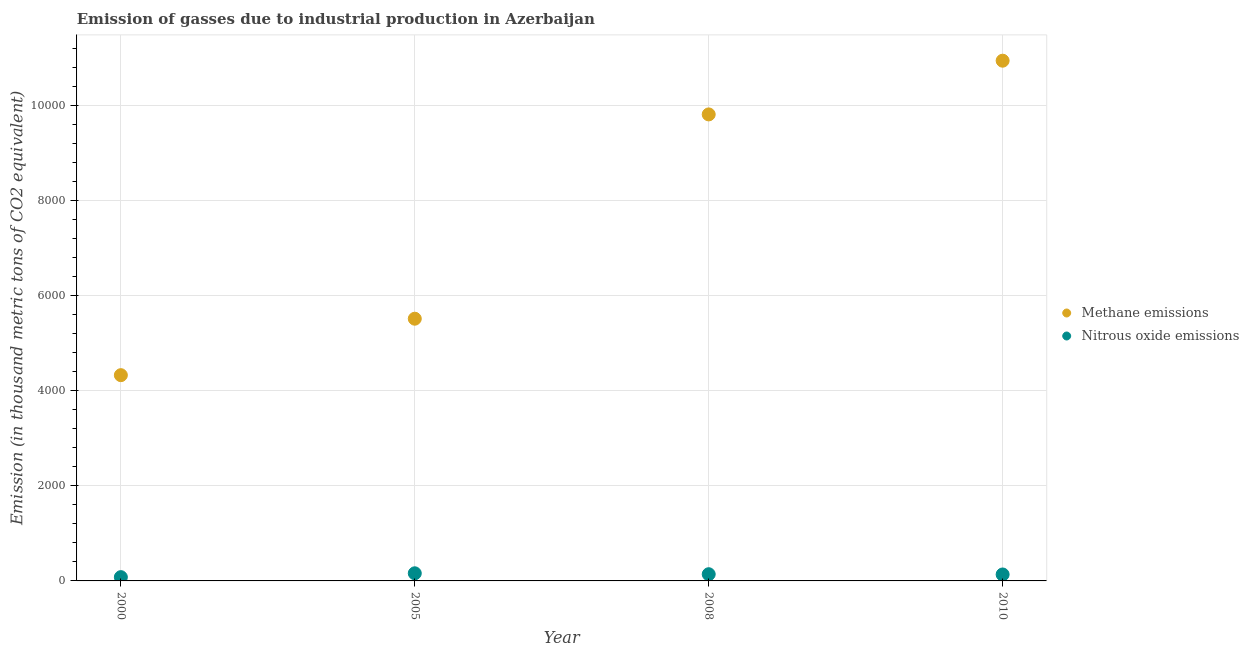How many different coloured dotlines are there?
Give a very brief answer. 2. Is the number of dotlines equal to the number of legend labels?
Make the answer very short. Yes. What is the amount of methane emissions in 2008?
Your answer should be very brief. 9812.4. Across all years, what is the maximum amount of nitrous oxide emissions?
Give a very brief answer. 160.4. Across all years, what is the minimum amount of methane emissions?
Keep it short and to the point. 4327.8. In which year was the amount of nitrous oxide emissions minimum?
Ensure brevity in your answer.  2000. What is the total amount of methane emissions in the graph?
Make the answer very short. 3.06e+04. What is the difference between the amount of methane emissions in 2005 and that in 2008?
Offer a very short reply. -4297.2. What is the difference between the amount of methane emissions in 2000 and the amount of nitrous oxide emissions in 2008?
Keep it short and to the point. 4186.8. What is the average amount of nitrous oxide emissions per year?
Offer a terse response. 129.15. In the year 2005, what is the difference between the amount of methane emissions and amount of nitrous oxide emissions?
Offer a very short reply. 5354.8. In how many years, is the amount of nitrous oxide emissions greater than 8800 thousand metric tons?
Ensure brevity in your answer.  0. What is the ratio of the amount of nitrous oxide emissions in 2005 to that in 2008?
Your answer should be compact. 1.14. Is the difference between the amount of methane emissions in 2005 and 2008 greater than the difference between the amount of nitrous oxide emissions in 2005 and 2008?
Keep it short and to the point. No. What is the difference between the highest and the second highest amount of nitrous oxide emissions?
Offer a very short reply. 19.4. What is the difference between the highest and the lowest amount of nitrous oxide emissions?
Make the answer very short. 80.9. Is the amount of nitrous oxide emissions strictly less than the amount of methane emissions over the years?
Keep it short and to the point. Yes. How many years are there in the graph?
Give a very brief answer. 4. What is the difference between two consecutive major ticks on the Y-axis?
Your answer should be compact. 2000. Are the values on the major ticks of Y-axis written in scientific E-notation?
Offer a terse response. No. Does the graph contain any zero values?
Ensure brevity in your answer.  No. Does the graph contain grids?
Provide a short and direct response. Yes. What is the title of the graph?
Your answer should be compact. Emission of gasses due to industrial production in Azerbaijan. Does "IMF nonconcessional" appear as one of the legend labels in the graph?
Offer a very short reply. No. What is the label or title of the X-axis?
Give a very brief answer. Year. What is the label or title of the Y-axis?
Your response must be concise. Emission (in thousand metric tons of CO2 equivalent). What is the Emission (in thousand metric tons of CO2 equivalent) in Methane emissions in 2000?
Your answer should be very brief. 4327.8. What is the Emission (in thousand metric tons of CO2 equivalent) in Nitrous oxide emissions in 2000?
Ensure brevity in your answer.  79.5. What is the Emission (in thousand metric tons of CO2 equivalent) in Methane emissions in 2005?
Provide a short and direct response. 5515.2. What is the Emission (in thousand metric tons of CO2 equivalent) in Nitrous oxide emissions in 2005?
Your answer should be very brief. 160.4. What is the Emission (in thousand metric tons of CO2 equivalent) in Methane emissions in 2008?
Make the answer very short. 9812.4. What is the Emission (in thousand metric tons of CO2 equivalent) of Nitrous oxide emissions in 2008?
Keep it short and to the point. 141. What is the Emission (in thousand metric tons of CO2 equivalent) in Methane emissions in 2010?
Your response must be concise. 1.09e+04. What is the Emission (in thousand metric tons of CO2 equivalent) in Nitrous oxide emissions in 2010?
Provide a short and direct response. 135.7. Across all years, what is the maximum Emission (in thousand metric tons of CO2 equivalent) in Methane emissions?
Provide a succinct answer. 1.09e+04. Across all years, what is the maximum Emission (in thousand metric tons of CO2 equivalent) of Nitrous oxide emissions?
Make the answer very short. 160.4. Across all years, what is the minimum Emission (in thousand metric tons of CO2 equivalent) in Methane emissions?
Your answer should be very brief. 4327.8. Across all years, what is the minimum Emission (in thousand metric tons of CO2 equivalent) in Nitrous oxide emissions?
Your answer should be compact. 79.5. What is the total Emission (in thousand metric tons of CO2 equivalent) of Methane emissions in the graph?
Provide a short and direct response. 3.06e+04. What is the total Emission (in thousand metric tons of CO2 equivalent) of Nitrous oxide emissions in the graph?
Your answer should be compact. 516.6. What is the difference between the Emission (in thousand metric tons of CO2 equivalent) of Methane emissions in 2000 and that in 2005?
Your answer should be very brief. -1187.4. What is the difference between the Emission (in thousand metric tons of CO2 equivalent) in Nitrous oxide emissions in 2000 and that in 2005?
Give a very brief answer. -80.9. What is the difference between the Emission (in thousand metric tons of CO2 equivalent) in Methane emissions in 2000 and that in 2008?
Offer a terse response. -5484.6. What is the difference between the Emission (in thousand metric tons of CO2 equivalent) of Nitrous oxide emissions in 2000 and that in 2008?
Your answer should be compact. -61.5. What is the difference between the Emission (in thousand metric tons of CO2 equivalent) of Methane emissions in 2000 and that in 2010?
Make the answer very short. -6614.3. What is the difference between the Emission (in thousand metric tons of CO2 equivalent) in Nitrous oxide emissions in 2000 and that in 2010?
Your response must be concise. -56.2. What is the difference between the Emission (in thousand metric tons of CO2 equivalent) of Methane emissions in 2005 and that in 2008?
Ensure brevity in your answer.  -4297.2. What is the difference between the Emission (in thousand metric tons of CO2 equivalent) in Nitrous oxide emissions in 2005 and that in 2008?
Offer a terse response. 19.4. What is the difference between the Emission (in thousand metric tons of CO2 equivalent) of Methane emissions in 2005 and that in 2010?
Keep it short and to the point. -5426.9. What is the difference between the Emission (in thousand metric tons of CO2 equivalent) in Nitrous oxide emissions in 2005 and that in 2010?
Offer a very short reply. 24.7. What is the difference between the Emission (in thousand metric tons of CO2 equivalent) of Methane emissions in 2008 and that in 2010?
Provide a succinct answer. -1129.7. What is the difference between the Emission (in thousand metric tons of CO2 equivalent) of Methane emissions in 2000 and the Emission (in thousand metric tons of CO2 equivalent) of Nitrous oxide emissions in 2005?
Offer a very short reply. 4167.4. What is the difference between the Emission (in thousand metric tons of CO2 equivalent) in Methane emissions in 2000 and the Emission (in thousand metric tons of CO2 equivalent) in Nitrous oxide emissions in 2008?
Your answer should be very brief. 4186.8. What is the difference between the Emission (in thousand metric tons of CO2 equivalent) of Methane emissions in 2000 and the Emission (in thousand metric tons of CO2 equivalent) of Nitrous oxide emissions in 2010?
Your response must be concise. 4192.1. What is the difference between the Emission (in thousand metric tons of CO2 equivalent) in Methane emissions in 2005 and the Emission (in thousand metric tons of CO2 equivalent) in Nitrous oxide emissions in 2008?
Your answer should be very brief. 5374.2. What is the difference between the Emission (in thousand metric tons of CO2 equivalent) in Methane emissions in 2005 and the Emission (in thousand metric tons of CO2 equivalent) in Nitrous oxide emissions in 2010?
Your answer should be compact. 5379.5. What is the difference between the Emission (in thousand metric tons of CO2 equivalent) of Methane emissions in 2008 and the Emission (in thousand metric tons of CO2 equivalent) of Nitrous oxide emissions in 2010?
Your response must be concise. 9676.7. What is the average Emission (in thousand metric tons of CO2 equivalent) in Methane emissions per year?
Ensure brevity in your answer.  7649.38. What is the average Emission (in thousand metric tons of CO2 equivalent) of Nitrous oxide emissions per year?
Your answer should be compact. 129.15. In the year 2000, what is the difference between the Emission (in thousand metric tons of CO2 equivalent) in Methane emissions and Emission (in thousand metric tons of CO2 equivalent) in Nitrous oxide emissions?
Give a very brief answer. 4248.3. In the year 2005, what is the difference between the Emission (in thousand metric tons of CO2 equivalent) of Methane emissions and Emission (in thousand metric tons of CO2 equivalent) of Nitrous oxide emissions?
Provide a succinct answer. 5354.8. In the year 2008, what is the difference between the Emission (in thousand metric tons of CO2 equivalent) in Methane emissions and Emission (in thousand metric tons of CO2 equivalent) in Nitrous oxide emissions?
Your response must be concise. 9671.4. In the year 2010, what is the difference between the Emission (in thousand metric tons of CO2 equivalent) of Methane emissions and Emission (in thousand metric tons of CO2 equivalent) of Nitrous oxide emissions?
Your answer should be very brief. 1.08e+04. What is the ratio of the Emission (in thousand metric tons of CO2 equivalent) of Methane emissions in 2000 to that in 2005?
Offer a terse response. 0.78. What is the ratio of the Emission (in thousand metric tons of CO2 equivalent) of Nitrous oxide emissions in 2000 to that in 2005?
Offer a very short reply. 0.5. What is the ratio of the Emission (in thousand metric tons of CO2 equivalent) in Methane emissions in 2000 to that in 2008?
Your answer should be very brief. 0.44. What is the ratio of the Emission (in thousand metric tons of CO2 equivalent) in Nitrous oxide emissions in 2000 to that in 2008?
Offer a terse response. 0.56. What is the ratio of the Emission (in thousand metric tons of CO2 equivalent) in Methane emissions in 2000 to that in 2010?
Ensure brevity in your answer.  0.4. What is the ratio of the Emission (in thousand metric tons of CO2 equivalent) in Nitrous oxide emissions in 2000 to that in 2010?
Ensure brevity in your answer.  0.59. What is the ratio of the Emission (in thousand metric tons of CO2 equivalent) of Methane emissions in 2005 to that in 2008?
Provide a succinct answer. 0.56. What is the ratio of the Emission (in thousand metric tons of CO2 equivalent) of Nitrous oxide emissions in 2005 to that in 2008?
Offer a terse response. 1.14. What is the ratio of the Emission (in thousand metric tons of CO2 equivalent) of Methane emissions in 2005 to that in 2010?
Your answer should be very brief. 0.5. What is the ratio of the Emission (in thousand metric tons of CO2 equivalent) of Nitrous oxide emissions in 2005 to that in 2010?
Give a very brief answer. 1.18. What is the ratio of the Emission (in thousand metric tons of CO2 equivalent) of Methane emissions in 2008 to that in 2010?
Offer a terse response. 0.9. What is the ratio of the Emission (in thousand metric tons of CO2 equivalent) of Nitrous oxide emissions in 2008 to that in 2010?
Your answer should be very brief. 1.04. What is the difference between the highest and the second highest Emission (in thousand metric tons of CO2 equivalent) in Methane emissions?
Offer a very short reply. 1129.7. What is the difference between the highest and the second highest Emission (in thousand metric tons of CO2 equivalent) of Nitrous oxide emissions?
Keep it short and to the point. 19.4. What is the difference between the highest and the lowest Emission (in thousand metric tons of CO2 equivalent) in Methane emissions?
Your answer should be compact. 6614.3. What is the difference between the highest and the lowest Emission (in thousand metric tons of CO2 equivalent) of Nitrous oxide emissions?
Provide a short and direct response. 80.9. 